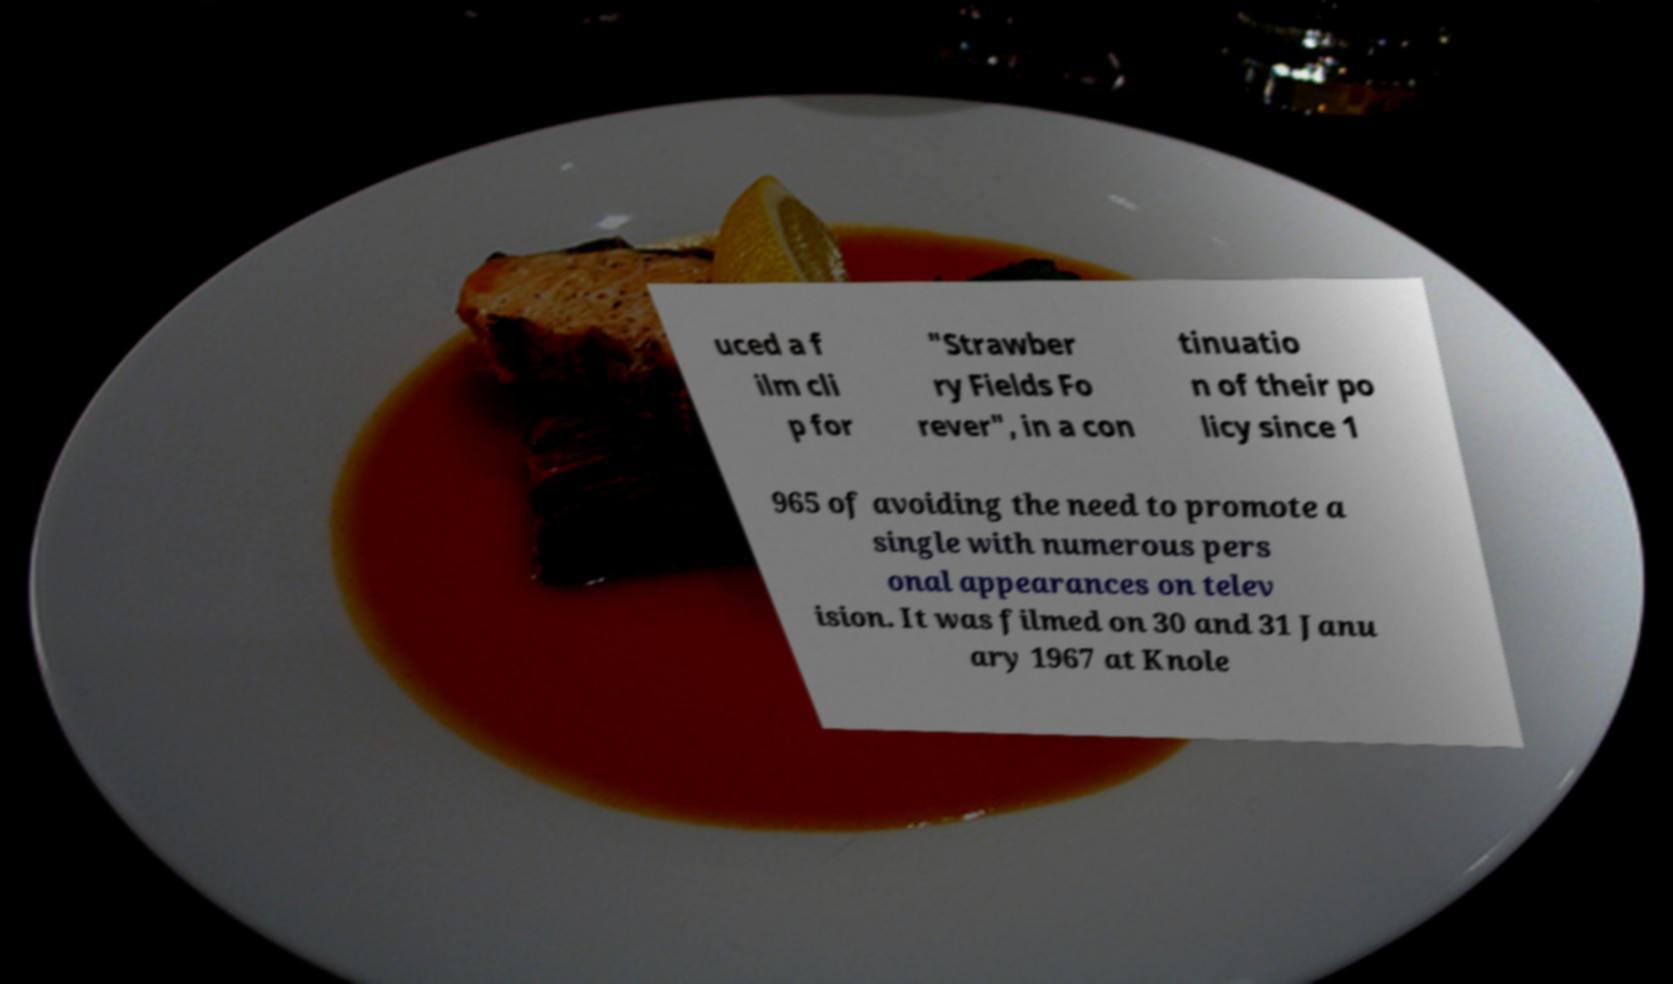What messages or text are displayed in this image? I need them in a readable, typed format. uced a f ilm cli p for "Strawber ry Fields Fo rever", in a con tinuatio n of their po licy since 1 965 of avoiding the need to promote a single with numerous pers onal appearances on telev ision. It was filmed on 30 and 31 Janu ary 1967 at Knole 